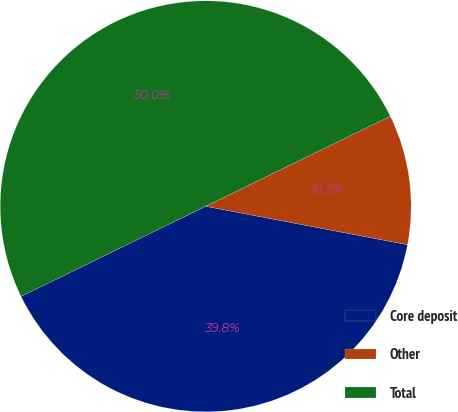Convert chart. <chart><loc_0><loc_0><loc_500><loc_500><pie_chart><fcel>Core deposit<fcel>Other<fcel>Total<nl><fcel>39.78%<fcel>10.22%<fcel>50.0%<nl></chart> 